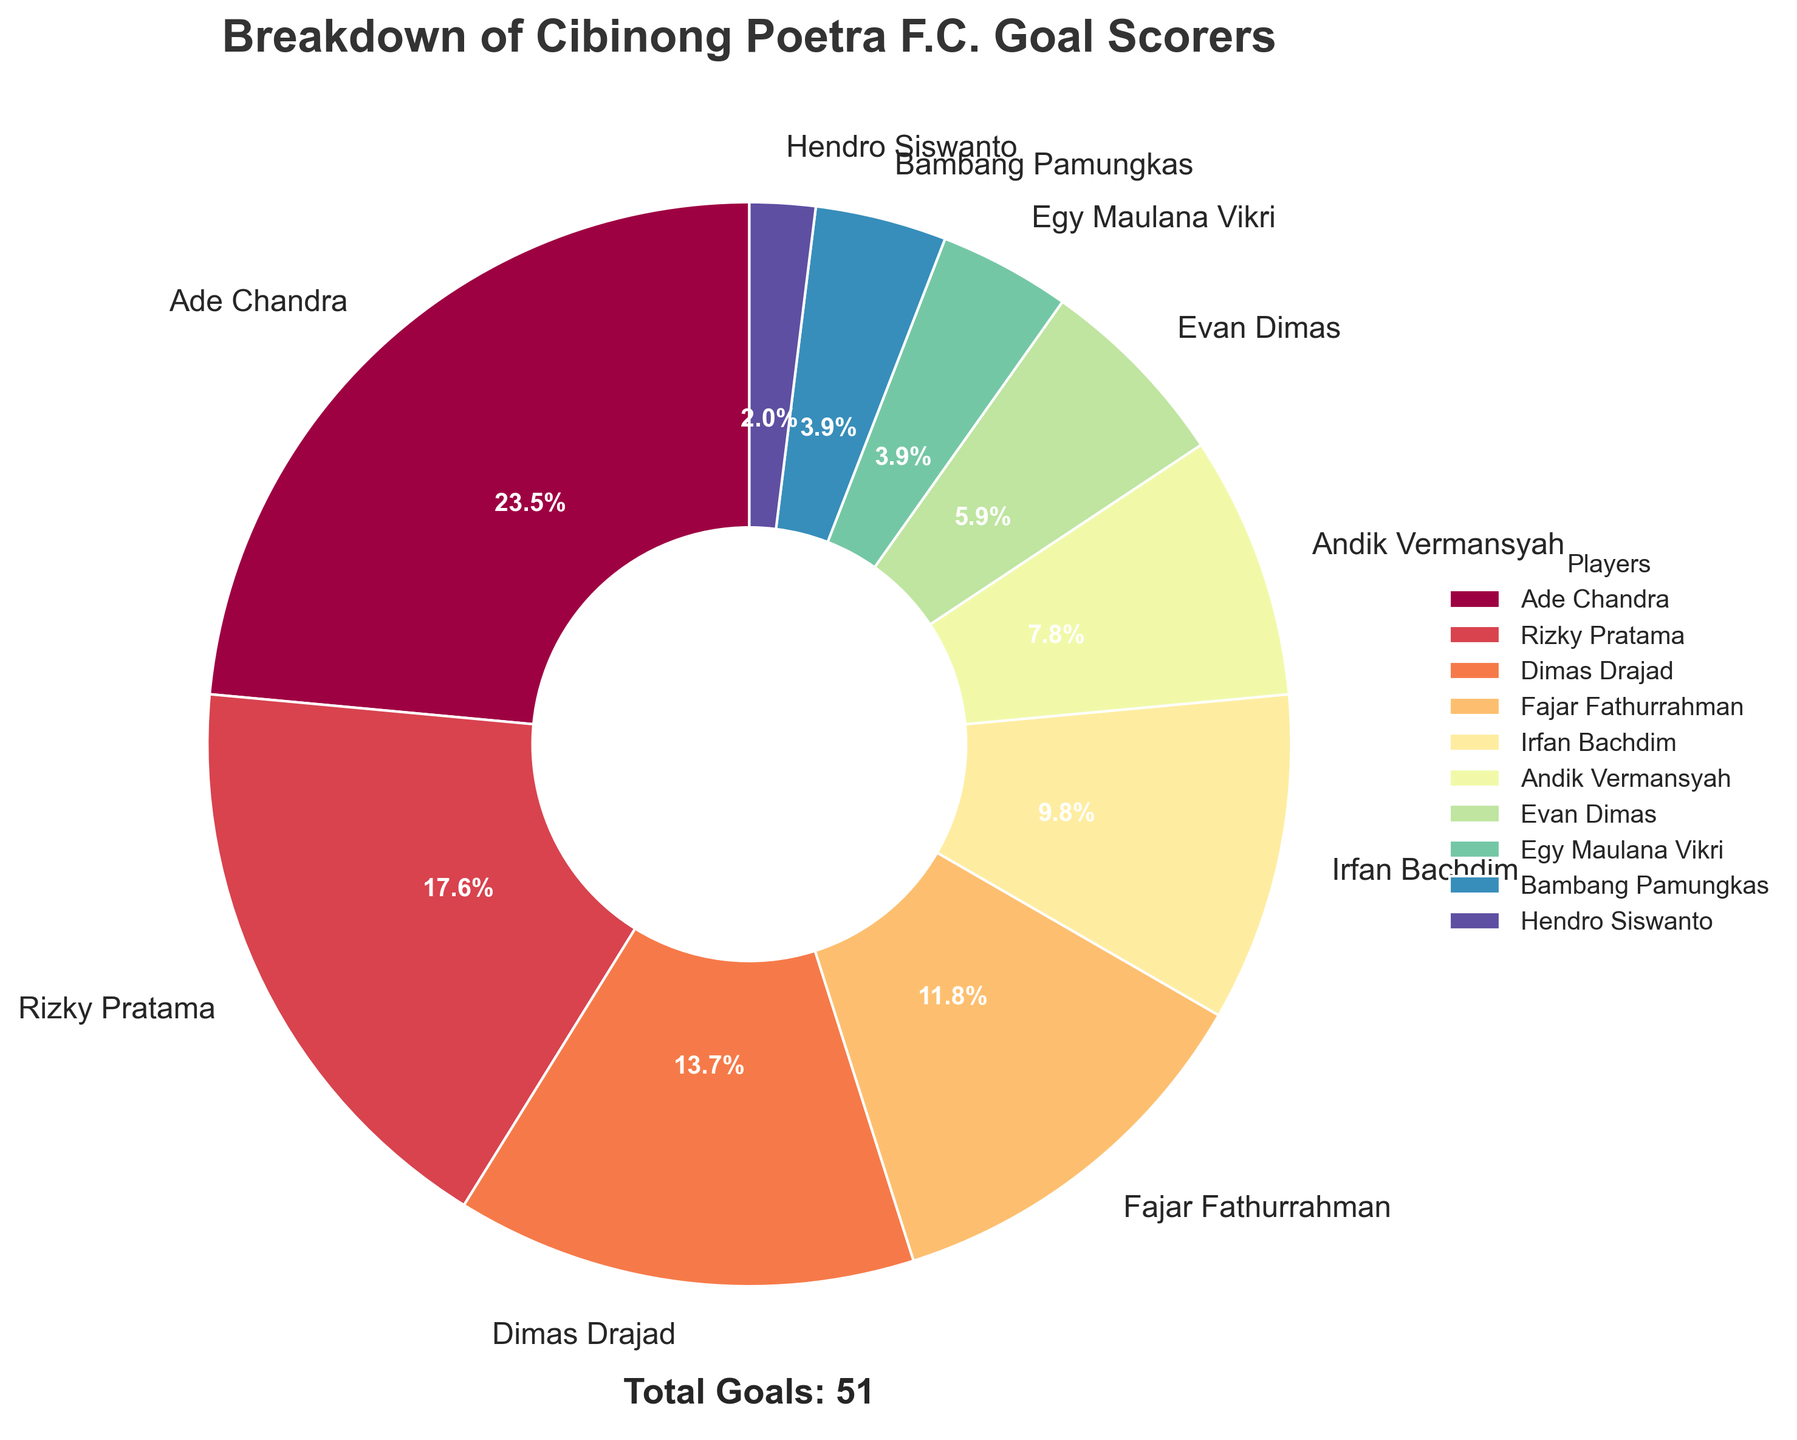What's the percentage of goals scored by Ade Chandra? Ade Chandra's goals (12) divided by the total goals (51) and multiplied by 100 gives the percentage. (12/51)*100 ≈ 23.5%
Answer: 23.5% How many more goals did Rizky Pratama score than Evan Dimas? Rizky Pratama scored 9 goals and Evan Dimas scored 3 goals. The difference is 9 - 3 = 6
Answer: 6 Which player scored more goals, Fajar Fathurrahman or Irfan Bachdim? Fajar Fathurrahman scored 6 goals and Irfan Bachdim scored 5 goals. 6 is greater than 5, so Fajar scored more
Answer: Fajar Fathurrahman Which player has the smallest slice in the pie chart? The smallest slice represents Hendro Siswanto, who scored 1 goal
Answer: Hendro Siswanto What is the total number of goals scored by players who scored fewer than 4 goals? Add goals of Evan Dimas (3), Egy Maulana Vikri (2), Bambang Pamungkas (2), and Hendro Siswanto (1). The total is 3 + 2 + 2 + 1 = 8
Answer: 8 What percentage of the total goals was scored by Dimas Drajad and Andik Vermansyah combined? Dimas Drajad scored 7 goals and Andik Vermansyah scored 4 goals, totaling 11 goals. 11/51*100 ≈ 21.6%
Answer: 21.6% Compare the goal contributions of Ade Chandra and Fajar Fathurrahman? Ade Chandra scored 12 goals while Fajar Fathurrahman scored 6 goals. Ade Chandra scored twice as many goals as Fajar Fathurrahman
Answer: Ade Chandra scored twice as many Which player between Bambang Pamungkas and Rizky Pratama has a larger slice and by how much percentage? Rizky Pratama scored 9 goals, whereas Bambang Pamungkas scored 2 goals. Rizky Pratama's slice is larger. The percentage difference is (9/51*100) - (2/51*100) ≈ 17.6% - 3.9% = 13.7%
Answer: Rizky Pratama by 13.7% If we combine the goals scored by Irfan Bachdim and Hendro Siswanto, would they have scored more than Dimas Drajad? Irfan Bachdim scored 5 goals and Hendro Siswanto scored 1, totaling 6 goals, which is less than the 7 goals scored by Dimas Drajad. Therefore, no
Answer: No What fraction of the total goals were scored by the top three goal scorers? The top three goal scorers are Ade Chandra (12), Rizky Pratama (9), and Dimas Drajad (7), totaling 28 goals. The fraction is 28/51
Answer: 28/51 